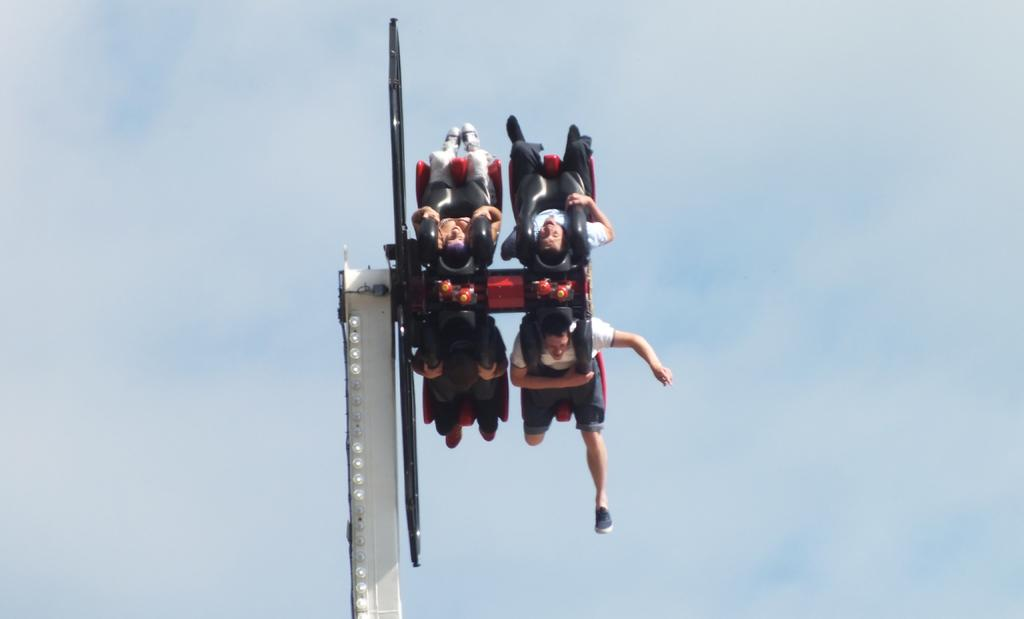How many people are in the image? There are four persons in the image. What are the four persons doing in the image? The four persons are sitting. What can be seen in the background of the image? The sky is visible in the image. What type of iron can be seen in the image? There is no iron present in the image. What color is the orange in the image? There is no orange present in the image. 